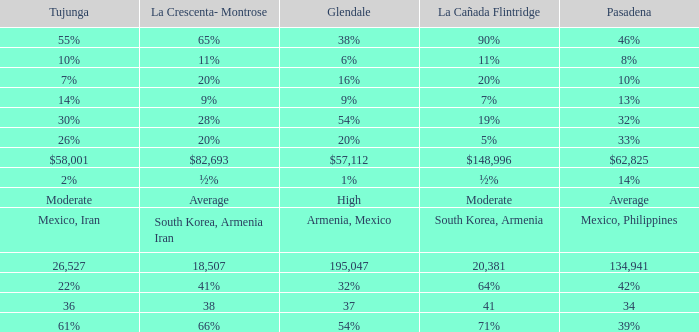What is the figure for Pasadena when Tujunga is 36? 34.0. 